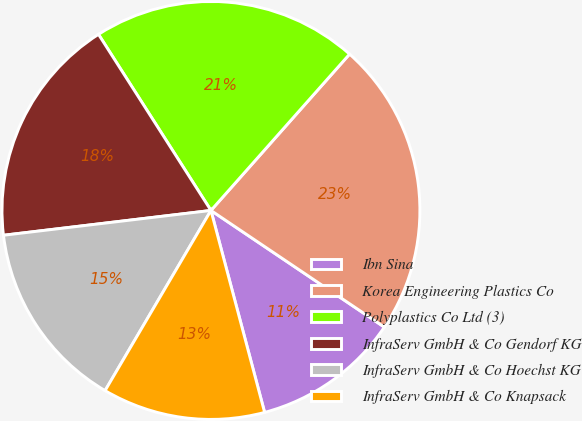<chart> <loc_0><loc_0><loc_500><loc_500><pie_chart><fcel>Ibn Sina<fcel>Korea Engineering Plastics Co<fcel>Polyplastics Co Ltd (3)<fcel>InfraServ GmbH & Co Gendorf KG<fcel>InfraServ GmbH & Co Hoechst KG<fcel>InfraServ GmbH & Co Knapsack<nl><fcel>11.44%<fcel>22.88%<fcel>20.59%<fcel>17.85%<fcel>14.65%<fcel>12.59%<nl></chart> 